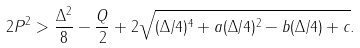<formula> <loc_0><loc_0><loc_500><loc_500>2 P ^ { 2 } > \frac { \Delta ^ { 2 } } { 8 } - \frac { Q } { 2 } + 2 \sqrt { ( \Delta / 4 ) ^ { 4 } + a ( \Delta / 4 ) ^ { 2 } - b ( \Delta / 4 ) + c } .</formula> 